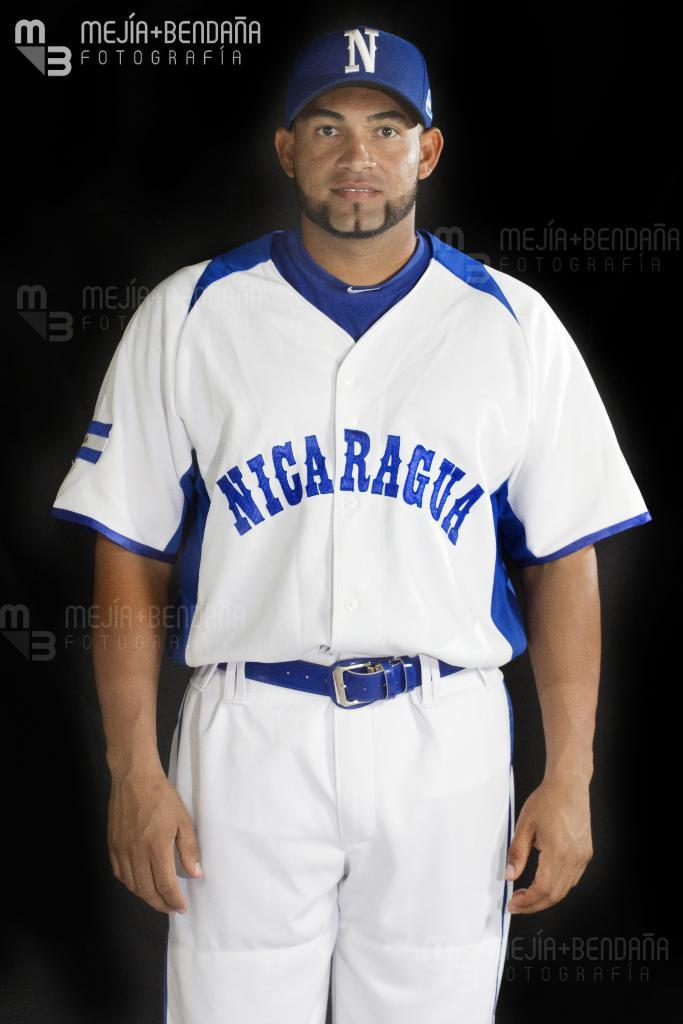<image>
Summarize the visual content of the image. Baseball player wearing a white jersey saying Nicaragua on it. 